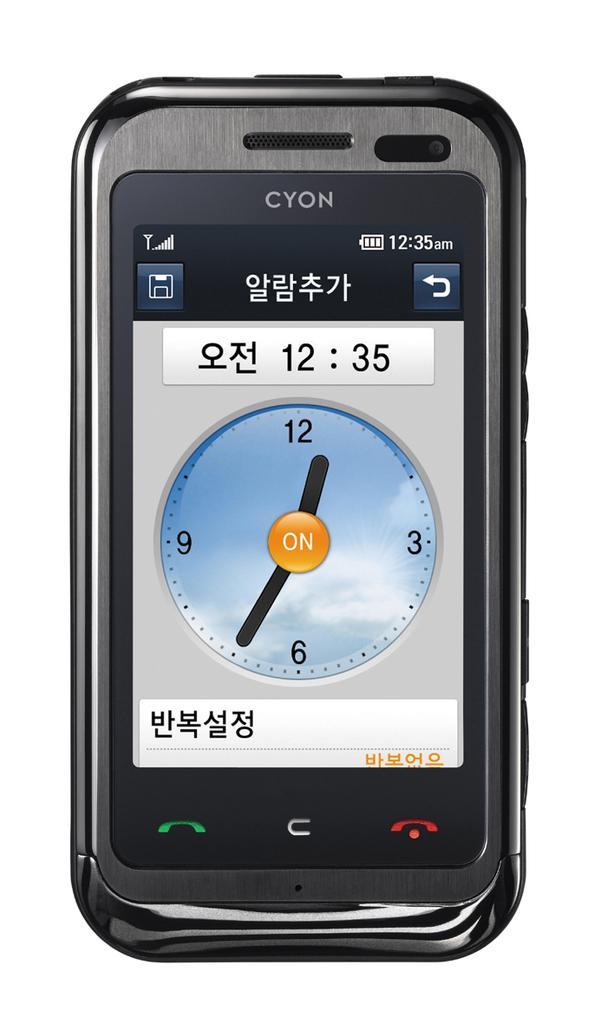<image>
Provide a brief description of the given image. A black cell phone says Cyon and shows an analog clock on the screen. 